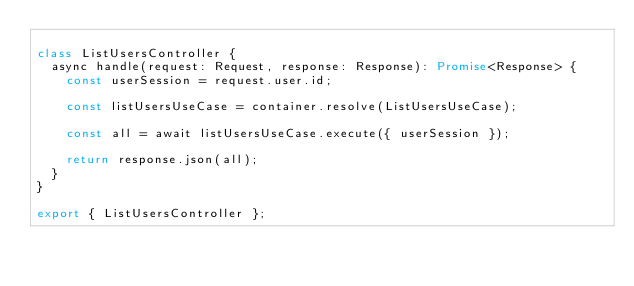<code> <loc_0><loc_0><loc_500><loc_500><_TypeScript_>
class ListUsersController {
  async handle(request: Request, response: Response): Promise<Response> {
    const userSession = request.user.id;

    const listUsersUseCase = container.resolve(ListUsersUseCase);

    const all = await listUsersUseCase.execute({ userSession });

    return response.json(all);
  }
}

export { ListUsersController };
</code> 